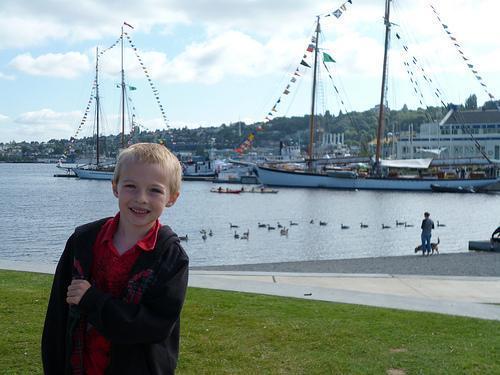How many boats are there?
Give a very brief answer. 2. 